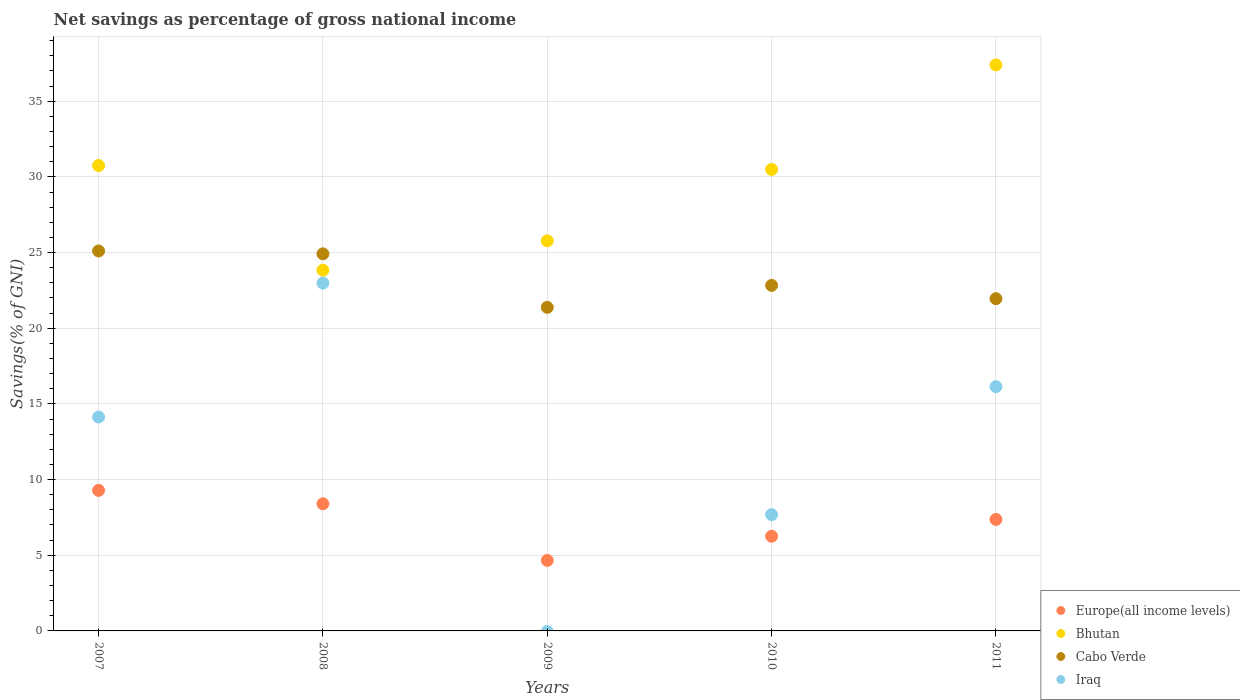How many different coloured dotlines are there?
Your response must be concise. 4. What is the total savings in Europe(all income levels) in 2007?
Offer a terse response. 9.29. Across all years, what is the maximum total savings in Cabo Verde?
Provide a short and direct response. 25.1. Across all years, what is the minimum total savings in Bhutan?
Provide a succinct answer. 23.84. What is the total total savings in Europe(all income levels) in the graph?
Your answer should be very brief. 35.97. What is the difference between the total savings in Iraq in 2008 and that in 2010?
Offer a terse response. 15.3. What is the difference between the total savings in Cabo Verde in 2008 and the total savings in Iraq in 2010?
Offer a very short reply. 17.23. What is the average total savings in Cabo Verde per year?
Ensure brevity in your answer.  23.24. In the year 2011, what is the difference between the total savings in Europe(all income levels) and total savings in Iraq?
Make the answer very short. -8.77. What is the ratio of the total savings in Bhutan in 2010 to that in 2011?
Provide a succinct answer. 0.82. Is the total savings in Cabo Verde in 2007 less than that in 2009?
Provide a succinct answer. No. Is the difference between the total savings in Europe(all income levels) in 2008 and 2010 greater than the difference between the total savings in Iraq in 2008 and 2010?
Offer a terse response. No. What is the difference between the highest and the second highest total savings in Iraq?
Provide a short and direct response. 6.84. What is the difference between the highest and the lowest total savings in Cabo Verde?
Give a very brief answer. 3.72. In how many years, is the total savings in Bhutan greater than the average total savings in Bhutan taken over all years?
Offer a very short reply. 3. Is the total savings in Bhutan strictly greater than the total savings in Europe(all income levels) over the years?
Offer a very short reply. Yes. Is the total savings in Cabo Verde strictly less than the total savings in Europe(all income levels) over the years?
Offer a very short reply. No. How many years are there in the graph?
Provide a succinct answer. 5. What is the difference between two consecutive major ticks on the Y-axis?
Your answer should be very brief. 5. Are the values on the major ticks of Y-axis written in scientific E-notation?
Your answer should be compact. No. Does the graph contain grids?
Your answer should be very brief. Yes. Where does the legend appear in the graph?
Offer a terse response. Bottom right. How many legend labels are there?
Your answer should be compact. 4. What is the title of the graph?
Offer a terse response. Net savings as percentage of gross national income. Does "South Asia" appear as one of the legend labels in the graph?
Make the answer very short. No. What is the label or title of the X-axis?
Your response must be concise. Years. What is the label or title of the Y-axis?
Make the answer very short. Savings(% of GNI). What is the Savings(% of GNI) of Europe(all income levels) in 2007?
Ensure brevity in your answer.  9.29. What is the Savings(% of GNI) of Bhutan in 2007?
Ensure brevity in your answer.  30.75. What is the Savings(% of GNI) of Cabo Verde in 2007?
Provide a succinct answer. 25.1. What is the Savings(% of GNI) of Iraq in 2007?
Your answer should be compact. 14.13. What is the Savings(% of GNI) of Europe(all income levels) in 2008?
Your answer should be compact. 8.4. What is the Savings(% of GNI) in Bhutan in 2008?
Make the answer very short. 23.84. What is the Savings(% of GNI) of Cabo Verde in 2008?
Make the answer very short. 24.91. What is the Savings(% of GNI) in Iraq in 2008?
Your answer should be compact. 22.98. What is the Savings(% of GNI) in Europe(all income levels) in 2009?
Your answer should be compact. 4.66. What is the Savings(% of GNI) of Bhutan in 2009?
Ensure brevity in your answer.  25.78. What is the Savings(% of GNI) of Cabo Verde in 2009?
Give a very brief answer. 21.38. What is the Savings(% of GNI) in Europe(all income levels) in 2010?
Provide a succinct answer. 6.26. What is the Savings(% of GNI) of Bhutan in 2010?
Your answer should be very brief. 30.49. What is the Savings(% of GNI) in Cabo Verde in 2010?
Provide a short and direct response. 22.83. What is the Savings(% of GNI) of Iraq in 2010?
Your answer should be very brief. 7.68. What is the Savings(% of GNI) of Europe(all income levels) in 2011?
Offer a very short reply. 7.37. What is the Savings(% of GNI) of Bhutan in 2011?
Your answer should be compact. 37.4. What is the Savings(% of GNI) in Cabo Verde in 2011?
Your answer should be very brief. 21.95. What is the Savings(% of GNI) of Iraq in 2011?
Your answer should be compact. 16.14. Across all years, what is the maximum Savings(% of GNI) in Europe(all income levels)?
Make the answer very short. 9.29. Across all years, what is the maximum Savings(% of GNI) of Bhutan?
Your answer should be very brief. 37.4. Across all years, what is the maximum Savings(% of GNI) of Cabo Verde?
Your answer should be compact. 25.1. Across all years, what is the maximum Savings(% of GNI) of Iraq?
Your answer should be very brief. 22.98. Across all years, what is the minimum Savings(% of GNI) of Europe(all income levels)?
Provide a succinct answer. 4.66. Across all years, what is the minimum Savings(% of GNI) of Bhutan?
Offer a very short reply. 23.84. Across all years, what is the minimum Savings(% of GNI) of Cabo Verde?
Your answer should be very brief. 21.38. Across all years, what is the minimum Savings(% of GNI) of Iraq?
Your response must be concise. 0. What is the total Savings(% of GNI) of Europe(all income levels) in the graph?
Keep it short and to the point. 35.97. What is the total Savings(% of GNI) in Bhutan in the graph?
Your answer should be very brief. 148.25. What is the total Savings(% of GNI) in Cabo Verde in the graph?
Ensure brevity in your answer.  116.18. What is the total Savings(% of GNI) in Iraq in the graph?
Provide a short and direct response. 60.93. What is the difference between the Savings(% of GNI) in Europe(all income levels) in 2007 and that in 2008?
Your answer should be compact. 0.89. What is the difference between the Savings(% of GNI) in Bhutan in 2007 and that in 2008?
Make the answer very short. 6.91. What is the difference between the Savings(% of GNI) of Cabo Verde in 2007 and that in 2008?
Your answer should be very brief. 0.19. What is the difference between the Savings(% of GNI) of Iraq in 2007 and that in 2008?
Your response must be concise. -8.85. What is the difference between the Savings(% of GNI) of Europe(all income levels) in 2007 and that in 2009?
Offer a very short reply. 4.63. What is the difference between the Savings(% of GNI) of Bhutan in 2007 and that in 2009?
Provide a short and direct response. 4.97. What is the difference between the Savings(% of GNI) of Cabo Verde in 2007 and that in 2009?
Your answer should be very brief. 3.72. What is the difference between the Savings(% of GNI) of Europe(all income levels) in 2007 and that in 2010?
Your response must be concise. 3.03. What is the difference between the Savings(% of GNI) of Bhutan in 2007 and that in 2010?
Ensure brevity in your answer.  0.26. What is the difference between the Savings(% of GNI) in Cabo Verde in 2007 and that in 2010?
Offer a terse response. 2.27. What is the difference between the Savings(% of GNI) of Iraq in 2007 and that in 2010?
Provide a short and direct response. 6.45. What is the difference between the Savings(% of GNI) in Europe(all income levels) in 2007 and that in 2011?
Offer a terse response. 1.92. What is the difference between the Savings(% of GNI) of Bhutan in 2007 and that in 2011?
Provide a short and direct response. -6.65. What is the difference between the Savings(% of GNI) in Cabo Verde in 2007 and that in 2011?
Provide a short and direct response. 3.15. What is the difference between the Savings(% of GNI) of Iraq in 2007 and that in 2011?
Keep it short and to the point. -2.01. What is the difference between the Savings(% of GNI) in Europe(all income levels) in 2008 and that in 2009?
Your answer should be compact. 3.74. What is the difference between the Savings(% of GNI) of Bhutan in 2008 and that in 2009?
Provide a succinct answer. -1.94. What is the difference between the Savings(% of GNI) in Cabo Verde in 2008 and that in 2009?
Offer a very short reply. 3.54. What is the difference between the Savings(% of GNI) of Europe(all income levels) in 2008 and that in 2010?
Offer a terse response. 2.14. What is the difference between the Savings(% of GNI) in Bhutan in 2008 and that in 2010?
Your response must be concise. -6.65. What is the difference between the Savings(% of GNI) in Cabo Verde in 2008 and that in 2010?
Provide a succinct answer. 2.08. What is the difference between the Savings(% of GNI) in Iraq in 2008 and that in 2010?
Give a very brief answer. 15.3. What is the difference between the Savings(% of GNI) in Europe(all income levels) in 2008 and that in 2011?
Offer a very short reply. 1.03. What is the difference between the Savings(% of GNI) of Bhutan in 2008 and that in 2011?
Your response must be concise. -13.56. What is the difference between the Savings(% of GNI) in Cabo Verde in 2008 and that in 2011?
Provide a short and direct response. 2.96. What is the difference between the Savings(% of GNI) of Iraq in 2008 and that in 2011?
Your answer should be very brief. 6.84. What is the difference between the Savings(% of GNI) of Europe(all income levels) in 2009 and that in 2010?
Your answer should be very brief. -1.6. What is the difference between the Savings(% of GNI) in Bhutan in 2009 and that in 2010?
Your response must be concise. -4.71. What is the difference between the Savings(% of GNI) of Cabo Verde in 2009 and that in 2010?
Make the answer very short. -1.45. What is the difference between the Savings(% of GNI) of Europe(all income levels) in 2009 and that in 2011?
Your answer should be very brief. -2.71. What is the difference between the Savings(% of GNI) in Bhutan in 2009 and that in 2011?
Provide a succinct answer. -11.62. What is the difference between the Savings(% of GNI) in Cabo Verde in 2009 and that in 2011?
Your answer should be very brief. -0.57. What is the difference between the Savings(% of GNI) of Europe(all income levels) in 2010 and that in 2011?
Your answer should be very brief. -1.11. What is the difference between the Savings(% of GNI) in Bhutan in 2010 and that in 2011?
Provide a short and direct response. -6.91. What is the difference between the Savings(% of GNI) of Cabo Verde in 2010 and that in 2011?
Ensure brevity in your answer.  0.88. What is the difference between the Savings(% of GNI) of Iraq in 2010 and that in 2011?
Provide a succinct answer. -8.46. What is the difference between the Savings(% of GNI) in Europe(all income levels) in 2007 and the Savings(% of GNI) in Bhutan in 2008?
Your answer should be very brief. -14.55. What is the difference between the Savings(% of GNI) of Europe(all income levels) in 2007 and the Savings(% of GNI) of Cabo Verde in 2008?
Your answer should be compact. -15.63. What is the difference between the Savings(% of GNI) of Europe(all income levels) in 2007 and the Savings(% of GNI) of Iraq in 2008?
Keep it short and to the point. -13.69. What is the difference between the Savings(% of GNI) in Bhutan in 2007 and the Savings(% of GNI) in Cabo Verde in 2008?
Your answer should be very brief. 5.83. What is the difference between the Savings(% of GNI) of Bhutan in 2007 and the Savings(% of GNI) of Iraq in 2008?
Offer a terse response. 7.77. What is the difference between the Savings(% of GNI) of Cabo Verde in 2007 and the Savings(% of GNI) of Iraq in 2008?
Provide a succinct answer. 2.12. What is the difference between the Savings(% of GNI) in Europe(all income levels) in 2007 and the Savings(% of GNI) in Bhutan in 2009?
Provide a succinct answer. -16.49. What is the difference between the Savings(% of GNI) in Europe(all income levels) in 2007 and the Savings(% of GNI) in Cabo Verde in 2009?
Ensure brevity in your answer.  -12.09. What is the difference between the Savings(% of GNI) in Bhutan in 2007 and the Savings(% of GNI) in Cabo Verde in 2009?
Offer a very short reply. 9.37. What is the difference between the Savings(% of GNI) in Europe(all income levels) in 2007 and the Savings(% of GNI) in Bhutan in 2010?
Provide a short and direct response. -21.2. What is the difference between the Savings(% of GNI) of Europe(all income levels) in 2007 and the Savings(% of GNI) of Cabo Verde in 2010?
Make the answer very short. -13.54. What is the difference between the Savings(% of GNI) in Europe(all income levels) in 2007 and the Savings(% of GNI) in Iraq in 2010?
Keep it short and to the point. 1.6. What is the difference between the Savings(% of GNI) in Bhutan in 2007 and the Savings(% of GNI) in Cabo Verde in 2010?
Provide a short and direct response. 7.92. What is the difference between the Savings(% of GNI) in Bhutan in 2007 and the Savings(% of GNI) in Iraq in 2010?
Provide a succinct answer. 23.07. What is the difference between the Savings(% of GNI) of Cabo Verde in 2007 and the Savings(% of GNI) of Iraq in 2010?
Keep it short and to the point. 17.42. What is the difference between the Savings(% of GNI) of Europe(all income levels) in 2007 and the Savings(% of GNI) of Bhutan in 2011?
Offer a very short reply. -28.11. What is the difference between the Savings(% of GNI) of Europe(all income levels) in 2007 and the Savings(% of GNI) of Cabo Verde in 2011?
Your response must be concise. -12.67. What is the difference between the Savings(% of GNI) in Europe(all income levels) in 2007 and the Savings(% of GNI) in Iraq in 2011?
Offer a terse response. -6.85. What is the difference between the Savings(% of GNI) of Bhutan in 2007 and the Savings(% of GNI) of Cabo Verde in 2011?
Provide a succinct answer. 8.8. What is the difference between the Savings(% of GNI) in Bhutan in 2007 and the Savings(% of GNI) in Iraq in 2011?
Your answer should be very brief. 14.61. What is the difference between the Savings(% of GNI) of Cabo Verde in 2007 and the Savings(% of GNI) of Iraq in 2011?
Your answer should be compact. 8.97. What is the difference between the Savings(% of GNI) in Europe(all income levels) in 2008 and the Savings(% of GNI) in Bhutan in 2009?
Provide a succinct answer. -17.38. What is the difference between the Savings(% of GNI) in Europe(all income levels) in 2008 and the Savings(% of GNI) in Cabo Verde in 2009?
Your answer should be compact. -12.98. What is the difference between the Savings(% of GNI) in Bhutan in 2008 and the Savings(% of GNI) in Cabo Verde in 2009?
Ensure brevity in your answer.  2.46. What is the difference between the Savings(% of GNI) in Europe(all income levels) in 2008 and the Savings(% of GNI) in Bhutan in 2010?
Provide a short and direct response. -22.09. What is the difference between the Savings(% of GNI) in Europe(all income levels) in 2008 and the Savings(% of GNI) in Cabo Verde in 2010?
Provide a short and direct response. -14.43. What is the difference between the Savings(% of GNI) of Europe(all income levels) in 2008 and the Savings(% of GNI) of Iraq in 2010?
Keep it short and to the point. 0.72. What is the difference between the Savings(% of GNI) of Bhutan in 2008 and the Savings(% of GNI) of Iraq in 2010?
Ensure brevity in your answer.  16.16. What is the difference between the Savings(% of GNI) of Cabo Verde in 2008 and the Savings(% of GNI) of Iraq in 2010?
Provide a short and direct response. 17.23. What is the difference between the Savings(% of GNI) in Europe(all income levels) in 2008 and the Savings(% of GNI) in Bhutan in 2011?
Offer a very short reply. -29. What is the difference between the Savings(% of GNI) in Europe(all income levels) in 2008 and the Savings(% of GNI) in Cabo Verde in 2011?
Your answer should be compact. -13.55. What is the difference between the Savings(% of GNI) of Europe(all income levels) in 2008 and the Savings(% of GNI) of Iraq in 2011?
Offer a terse response. -7.74. What is the difference between the Savings(% of GNI) of Bhutan in 2008 and the Savings(% of GNI) of Cabo Verde in 2011?
Offer a very short reply. 1.88. What is the difference between the Savings(% of GNI) of Bhutan in 2008 and the Savings(% of GNI) of Iraq in 2011?
Offer a terse response. 7.7. What is the difference between the Savings(% of GNI) of Cabo Verde in 2008 and the Savings(% of GNI) of Iraq in 2011?
Offer a very short reply. 8.78. What is the difference between the Savings(% of GNI) of Europe(all income levels) in 2009 and the Savings(% of GNI) of Bhutan in 2010?
Your response must be concise. -25.83. What is the difference between the Savings(% of GNI) of Europe(all income levels) in 2009 and the Savings(% of GNI) of Cabo Verde in 2010?
Make the answer very short. -18.17. What is the difference between the Savings(% of GNI) of Europe(all income levels) in 2009 and the Savings(% of GNI) of Iraq in 2010?
Provide a succinct answer. -3.02. What is the difference between the Savings(% of GNI) of Bhutan in 2009 and the Savings(% of GNI) of Cabo Verde in 2010?
Provide a short and direct response. 2.95. What is the difference between the Savings(% of GNI) of Bhutan in 2009 and the Savings(% of GNI) of Iraq in 2010?
Your answer should be very brief. 18.09. What is the difference between the Savings(% of GNI) of Cabo Verde in 2009 and the Savings(% of GNI) of Iraq in 2010?
Give a very brief answer. 13.7. What is the difference between the Savings(% of GNI) in Europe(all income levels) in 2009 and the Savings(% of GNI) in Bhutan in 2011?
Provide a short and direct response. -32.74. What is the difference between the Savings(% of GNI) in Europe(all income levels) in 2009 and the Savings(% of GNI) in Cabo Verde in 2011?
Your answer should be very brief. -17.29. What is the difference between the Savings(% of GNI) of Europe(all income levels) in 2009 and the Savings(% of GNI) of Iraq in 2011?
Offer a terse response. -11.48. What is the difference between the Savings(% of GNI) of Bhutan in 2009 and the Savings(% of GNI) of Cabo Verde in 2011?
Your response must be concise. 3.82. What is the difference between the Savings(% of GNI) of Bhutan in 2009 and the Savings(% of GNI) of Iraq in 2011?
Your answer should be very brief. 9.64. What is the difference between the Savings(% of GNI) of Cabo Verde in 2009 and the Savings(% of GNI) of Iraq in 2011?
Keep it short and to the point. 5.24. What is the difference between the Savings(% of GNI) of Europe(all income levels) in 2010 and the Savings(% of GNI) of Bhutan in 2011?
Keep it short and to the point. -31.14. What is the difference between the Savings(% of GNI) in Europe(all income levels) in 2010 and the Savings(% of GNI) in Cabo Verde in 2011?
Provide a succinct answer. -15.7. What is the difference between the Savings(% of GNI) in Europe(all income levels) in 2010 and the Savings(% of GNI) in Iraq in 2011?
Provide a succinct answer. -9.88. What is the difference between the Savings(% of GNI) of Bhutan in 2010 and the Savings(% of GNI) of Cabo Verde in 2011?
Make the answer very short. 8.54. What is the difference between the Savings(% of GNI) of Bhutan in 2010 and the Savings(% of GNI) of Iraq in 2011?
Your answer should be compact. 14.35. What is the difference between the Savings(% of GNI) of Cabo Verde in 2010 and the Savings(% of GNI) of Iraq in 2011?
Offer a very short reply. 6.69. What is the average Savings(% of GNI) of Europe(all income levels) per year?
Make the answer very short. 7.19. What is the average Savings(% of GNI) in Bhutan per year?
Keep it short and to the point. 29.65. What is the average Savings(% of GNI) in Cabo Verde per year?
Your response must be concise. 23.24. What is the average Savings(% of GNI) in Iraq per year?
Give a very brief answer. 12.19. In the year 2007, what is the difference between the Savings(% of GNI) in Europe(all income levels) and Savings(% of GNI) in Bhutan?
Provide a succinct answer. -21.46. In the year 2007, what is the difference between the Savings(% of GNI) of Europe(all income levels) and Savings(% of GNI) of Cabo Verde?
Your answer should be compact. -15.82. In the year 2007, what is the difference between the Savings(% of GNI) of Europe(all income levels) and Savings(% of GNI) of Iraq?
Make the answer very short. -4.85. In the year 2007, what is the difference between the Savings(% of GNI) in Bhutan and Savings(% of GNI) in Cabo Verde?
Your answer should be very brief. 5.64. In the year 2007, what is the difference between the Savings(% of GNI) in Bhutan and Savings(% of GNI) in Iraq?
Give a very brief answer. 16.62. In the year 2007, what is the difference between the Savings(% of GNI) of Cabo Verde and Savings(% of GNI) of Iraq?
Your answer should be compact. 10.97. In the year 2008, what is the difference between the Savings(% of GNI) in Europe(all income levels) and Savings(% of GNI) in Bhutan?
Keep it short and to the point. -15.44. In the year 2008, what is the difference between the Savings(% of GNI) of Europe(all income levels) and Savings(% of GNI) of Cabo Verde?
Give a very brief answer. -16.52. In the year 2008, what is the difference between the Savings(% of GNI) in Europe(all income levels) and Savings(% of GNI) in Iraq?
Offer a terse response. -14.58. In the year 2008, what is the difference between the Savings(% of GNI) in Bhutan and Savings(% of GNI) in Cabo Verde?
Provide a short and direct response. -1.08. In the year 2008, what is the difference between the Savings(% of GNI) in Bhutan and Savings(% of GNI) in Iraq?
Your answer should be compact. 0.86. In the year 2008, what is the difference between the Savings(% of GNI) in Cabo Verde and Savings(% of GNI) in Iraq?
Your answer should be compact. 1.93. In the year 2009, what is the difference between the Savings(% of GNI) in Europe(all income levels) and Savings(% of GNI) in Bhutan?
Ensure brevity in your answer.  -21.12. In the year 2009, what is the difference between the Savings(% of GNI) in Europe(all income levels) and Savings(% of GNI) in Cabo Verde?
Offer a terse response. -16.72. In the year 2009, what is the difference between the Savings(% of GNI) of Bhutan and Savings(% of GNI) of Cabo Verde?
Make the answer very short. 4.4. In the year 2010, what is the difference between the Savings(% of GNI) in Europe(all income levels) and Savings(% of GNI) in Bhutan?
Your answer should be very brief. -24.23. In the year 2010, what is the difference between the Savings(% of GNI) of Europe(all income levels) and Savings(% of GNI) of Cabo Verde?
Give a very brief answer. -16.57. In the year 2010, what is the difference between the Savings(% of GNI) of Europe(all income levels) and Savings(% of GNI) of Iraq?
Give a very brief answer. -1.42. In the year 2010, what is the difference between the Savings(% of GNI) of Bhutan and Savings(% of GNI) of Cabo Verde?
Your answer should be very brief. 7.66. In the year 2010, what is the difference between the Savings(% of GNI) in Bhutan and Savings(% of GNI) in Iraq?
Your response must be concise. 22.81. In the year 2010, what is the difference between the Savings(% of GNI) in Cabo Verde and Savings(% of GNI) in Iraq?
Provide a short and direct response. 15.15. In the year 2011, what is the difference between the Savings(% of GNI) in Europe(all income levels) and Savings(% of GNI) in Bhutan?
Your answer should be compact. -30.03. In the year 2011, what is the difference between the Savings(% of GNI) in Europe(all income levels) and Savings(% of GNI) in Cabo Verde?
Your answer should be compact. -14.58. In the year 2011, what is the difference between the Savings(% of GNI) of Europe(all income levels) and Savings(% of GNI) of Iraq?
Offer a very short reply. -8.77. In the year 2011, what is the difference between the Savings(% of GNI) in Bhutan and Savings(% of GNI) in Cabo Verde?
Ensure brevity in your answer.  15.45. In the year 2011, what is the difference between the Savings(% of GNI) of Bhutan and Savings(% of GNI) of Iraq?
Ensure brevity in your answer.  21.26. In the year 2011, what is the difference between the Savings(% of GNI) in Cabo Verde and Savings(% of GNI) in Iraq?
Your answer should be very brief. 5.82. What is the ratio of the Savings(% of GNI) in Europe(all income levels) in 2007 to that in 2008?
Keep it short and to the point. 1.11. What is the ratio of the Savings(% of GNI) in Bhutan in 2007 to that in 2008?
Your answer should be very brief. 1.29. What is the ratio of the Savings(% of GNI) of Cabo Verde in 2007 to that in 2008?
Your answer should be compact. 1.01. What is the ratio of the Savings(% of GNI) of Iraq in 2007 to that in 2008?
Your answer should be compact. 0.61. What is the ratio of the Savings(% of GNI) in Europe(all income levels) in 2007 to that in 2009?
Make the answer very short. 1.99. What is the ratio of the Savings(% of GNI) in Bhutan in 2007 to that in 2009?
Provide a short and direct response. 1.19. What is the ratio of the Savings(% of GNI) of Cabo Verde in 2007 to that in 2009?
Provide a succinct answer. 1.17. What is the ratio of the Savings(% of GNI) of Europe(all income levels) in 2007 to that in 2010?
Your answer should be very brief. 1.48. What is the ratio of the Savings(% of GNI) of Bhutan in 2007 to that in 2010?
Keep it short and to the point. 1.01. What is the ratio of the Savings(% of GNI) in Cabo Verde in 2007 to that in 2010?
Your answer should be compact. 1.1. What is the ratio of the Savings(% of GNI) of Iraq in 2007 to that in 2010?
Your response must be concise. 1.84. What is the ratio of the Savings(% of GNI) in Europe(all income levels) in 2007 to that in 2011?
Your response must be concise. 1.26. What is the ratio of the Savings(% of GNI) in Bhutan in 2007 to that in 2011?
Your answer should be compact. 0.82. What is the ratio of the Savings(% of GNI) of Cabo Verde in 2007 to that in 2011?
Ensure brevity in your answer.  1.14. What is the ratio of the Savings(% of GNI) in Iraq in 2007 to that in 2011?
Ensure brevity in your answer.  0.88. What is the ratio of the Savings(% of GNI) of Europe(all income levels) in 2008 to that in 2009?
Make the answer very short. 1.8. What is the ratio of the Savings(% of GNI) of Bhutan in 2008 to that in 2009?
Make the answer very short. 0.92. What is the ratio of the Savings(% of GNI) in Cabo Verde in 2008 to that in 2009?
Make the answer very short. 1.17. What is the ratio of the Savings(% of GNI) in Europe(all income levels) in 2008 to that in 2010?
Provide a succinct answer. 1.34. What is the ratio of the Savings(% of GNI) in Bhutan in 2008 to that in 2010?
Ensure brevity in your answer.  0.78. What is the ratio of the Savings(% of GNI) of Cabo Verde in 2008 to that in 2010?
Offer a very short reply. 1.09. What is the ratio of the Savings(% of GNI) of Iraq in 2008 to that in 2010?
Keep it short and to the point. 2.99. What is the ratio of the Savings(% of GNI) in Europe(all income levels) in 2008 to that in 2011?
Your answer should be compact. 1.14. What is the ratio of the Savings(% of GNI) of Bhutan in 2008 to that in 2011?
Keep it short and to the point. 0.64. What is the ratio of the Savings(% of GNI) in Cabo Verde in 2008 to that in 2011?
Keep it short and to the point. 1.13. What is the ratio of the Savings(% of GNI) of Iraq in 2008 to that in 2011?
Your answer should be compact. 1.42. What is the ratio of the Savings(% of GNI) in Europe(all income levels) in 2009 to that in 2010?
Ensure brevity in your answer.  0.74. What is the ratio of the Savings(% of GNI) in Bhutan in 2009 to that in 2010?
Your answer should be compact. 0.85. What is the ratio of the Savings(% of GNI) in Cabo Verde in 2009 to that in 2010?
Keep it short and to the point. 0.94. What is the ratio of the Savings(% of GNI) in Europe(all income levels) in 2009 to that in 2011?
Offer a very short reply. 0.63. What is the ratio of the Savings(% of GNI) in Bhutan in 2009 to that in 2011?
Provide a succinct answer. 0.69. What is the ratio of the Savings(% of GNI) in Cabo Verde in 2009 to that in 2011?
Provide a short and direct response. 0.97. What is the ratio of the Savings(% of GNI) in Europe(all income levels) in 2010 to that in 2011?
Your answer should be very brief. 0.85. What is the ratio of the Savings(% of GNI) in Bhutan in 2010 to that in 2011?
Provide a succinct answer. 0.82. What is the ratio of the Savings(% of GNI) in Cabo Verde in 2010 to that in 2011?
Your answer should be very brief. 1.04. What is the ratio of the Savings(% of GNI) of Iraq in 2010 to that in 2011?
Provide a short and direct response. 0.48. What is the difference between the highest and the second highest Savings(% of GNI) of Europe(all income levels)?
Offer a terse response. 0.89. What is the difference between the highest and the second highest Savings(% of GNI) of Bhutan?
Your response must be concise. 6.65. What is the difference between the highest and the second highest Savings(% of GNI) of Cabo Verde?
Keep it short and to the point. 0.19. What is the difference between the highest and the second highest Savings(% of GNI) of Iraq?
Offer a very short reply. 6.84. What is the difference between the highest and the lowest Savings(% of GNI) in Europe(all income levels)?
Keep it short and to the point. 4.63. What is the difference between the highest and the lowest Savings(% of GNI) in Bhutan?
Provide a short and direct response. 13.56. What is the difference between the highest and the lowest Savings(% of GNI) of Cabo Verde?
Ensure brevity in your answer.  3.72. What is the difference between the highest and the lowest Savings(% of GNI) in Iraq?
Your answer should be very brief. 22.98. 